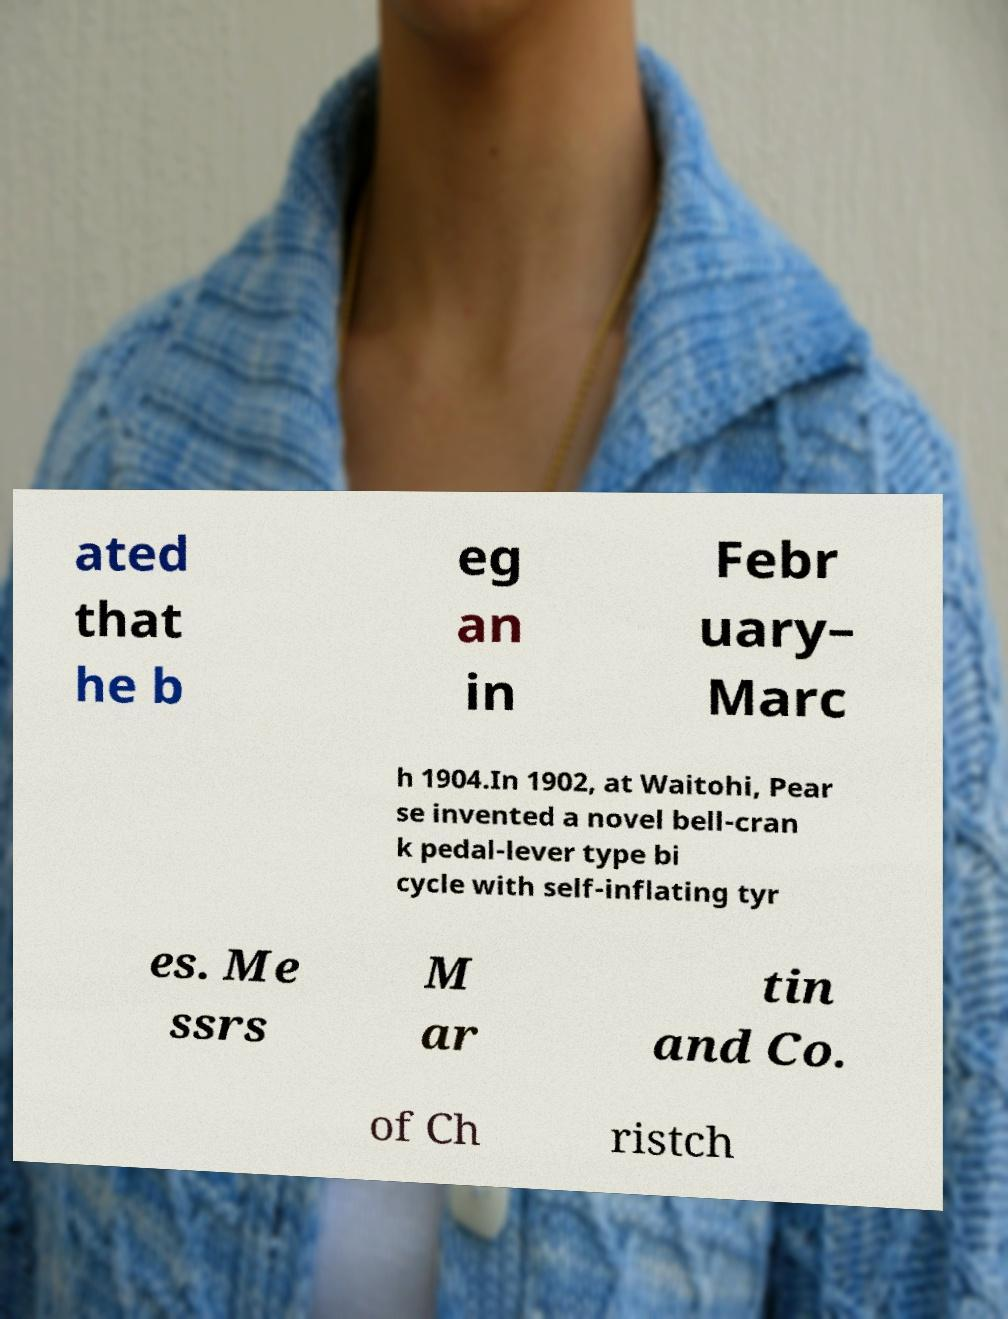Please read and relay the text visible in this image. What does it say? ated that he b eg an in Febr uary– Marc h 1904.In 1902, at Waitohi, Pear se invented a novel bell-cran k pedal-lever type bi cycle with self-inflating tyr es. Me ssrs M ar tin and Co. of Ch ristch 